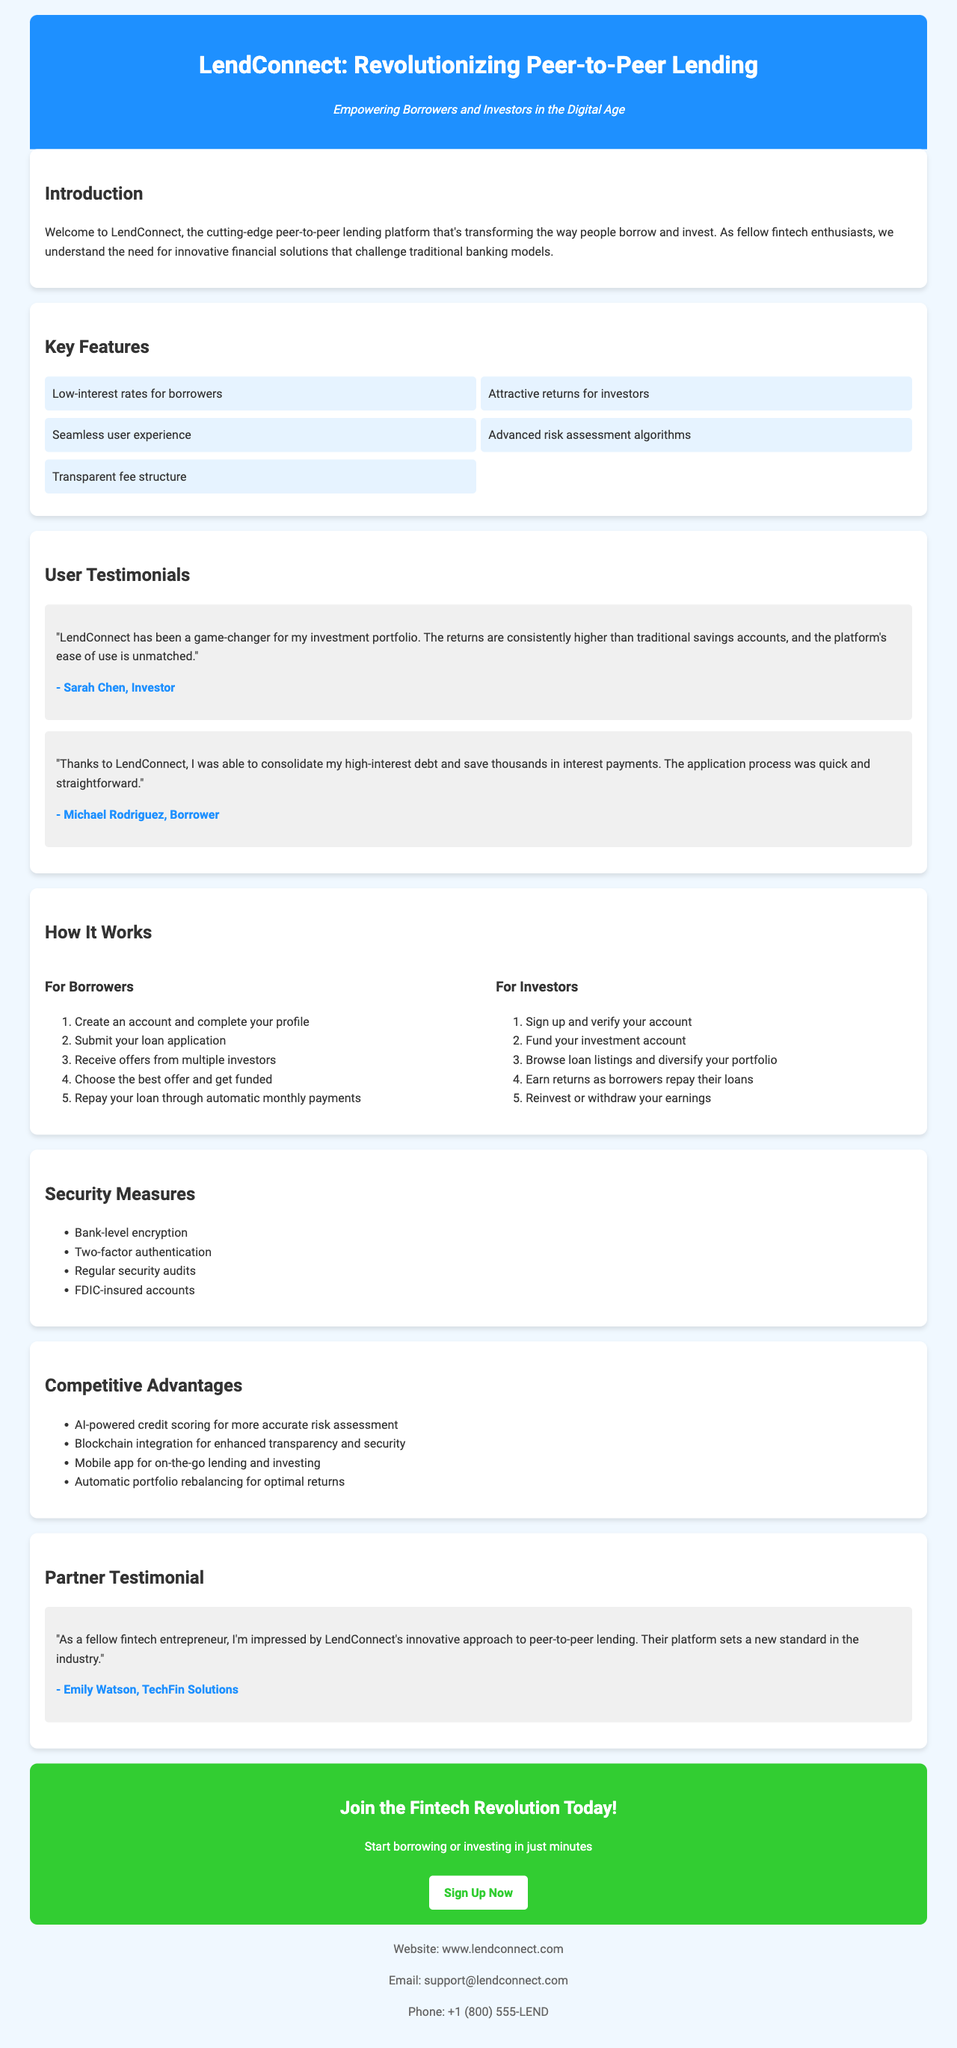What is the title of the brochure? The title is clearly stated at the top of the document.
Answer: LendConnect: Revolutionizing Peer-to-Peer Lending What is the tagline associated with LendConnect? The tagline specifies the platform's mission and is found under the title.
Answer: Empowering Borrowers and Investors in the Digital Age Who is the borrower testimonial provided by? The document lists both investor and borrower testimonials, specifying the borrower's name.
Answer: Michael Rodriguez How many steps are listed for borrowers in the "How It Works" section? Counting through the steps provided for borrowers will yield this number.
Answer: 5 What security measure is mentioned first in the document? The first item listed under security measures indicates the initial measure for safety.
Answer: Bank-level encryption Which company provided a partner testimonial? The document includes a testimonial from a partner, specifying the partner's company.
Answer: TechFin Solutions What call-to-action does LendConnect provide? Identifying the text within the call-to-action section reveals this information.
Answer: Sign Up Now What is one of the competitive advantages mentioned? The document has a list of competitive advantages, any of which can be identified.
Answer: AI-powered credit scoring for more accurate risk assessment How does LendConnect ensure account security? The document lists several security measures ensuring safety, focusing on encryption and authentication methods.
Answer: Two-factor authentication 